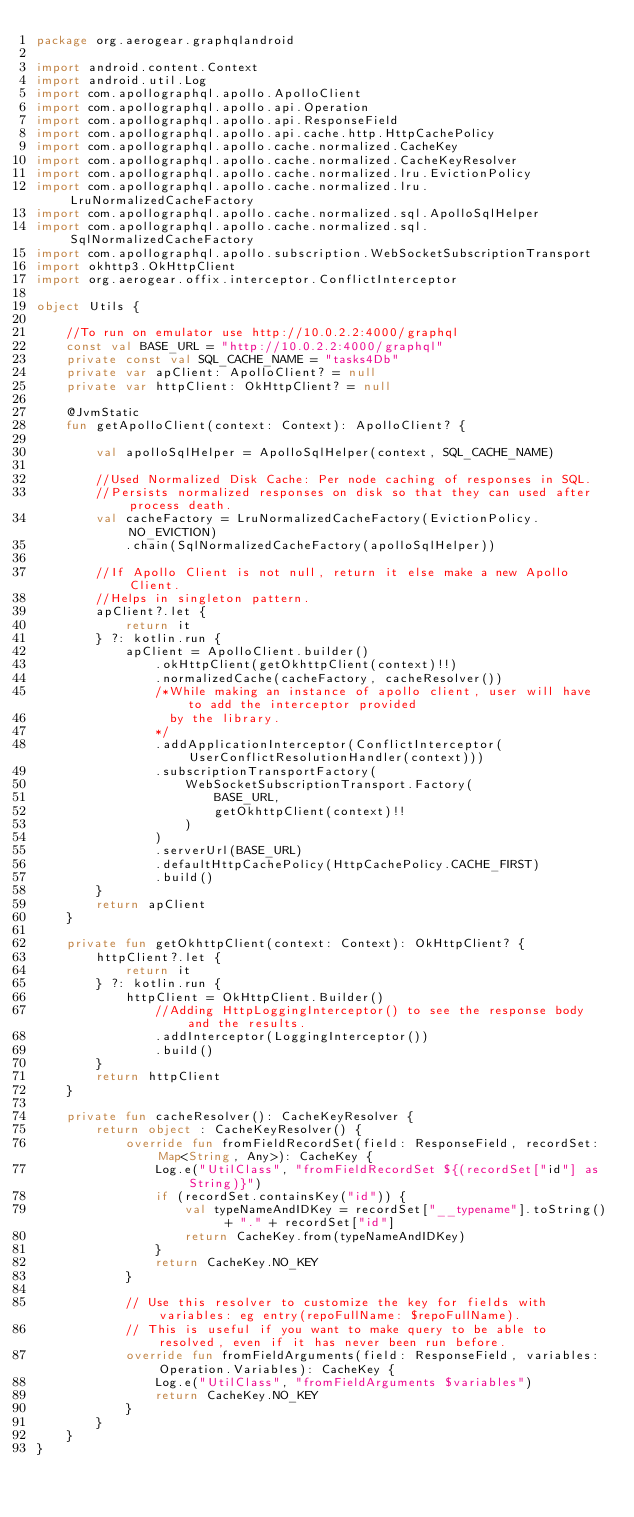<code> <loc_0><loc_0><loc_500><loc_500><_Kotlin_>package org.aerogear.graphqlandroid

import android.content.Context
import android.util.Log
import com.apollographql.apollo.ApolloClient
import com.apollographql.apollo.api.Operation
import com.apollographql.apollo.api.ResponseField
import com.apollographql.apollo.api.cache.http.HttpCachePolicy
import com.apollographql.apollo.cache.normalized.CacheKey
import com.apollographql.apollo.cache.normalized.CacheKeyResolver
import com.apollographql.apollo.cache.normalized.lru.EvictionPolicy
import com.apollographql.apollo.cache.normalized.lru.LruNormalizedCacheFactory
import com.apollographql.apollo.cache.normalized.sql.ApolloSqlHelper
import com.apollographql.apollo.cache.normalized.sql.SqlNormalizedCacheFactory
import com.apollographql.apollo.subscription.WebSocketSubscriptionTransport
import okhttp3.OkHttpClient
import org.aerogear.offix.interceptor.ConflictInterceptor

object Utils {

    //To run on emulator use http://10.0.2.2:4000/graphql
    const val BASE_URL = "http://10.0.2.2:4000/graphql"
    private const val SQL_CACHE_NAME = "tasks4Db"
    private var apClient: ApolloClient? = null
    private var httpClient: OkHttpClient? = null

    @JvmStatic
    fun getApolloClient(context: Context): ApolloClient? {

        val apolloSqlHelper = ApolloSqlHelper(context, SQL_CACHE_NAME)

        //Used Normalized Disk Cache: Per node caching of responses in SQL.
        //Persists normalized responses on disk so that they can used after process death.
        val cacheFactory = LruNormalizedCacheFactory(EvictionPolicy.NO_EVICTION)
            .chain(SqlNormalizedCacheFactory(apolloSqlHelper))

        //If Apollo Client is not null, return it else make a new Apollo Client.
        //Helps in singleton pattern.
        apClient?.let {
            return it
        } ?: kotlin.run {
            apClient = ApolloClient.builder()
                .okHttpClient(getOkhttpClient(context)!!)
                .normalizedCache(cacheFactory, cacheResolver())
                /*While making an instance of apollo client, user will have to add the interceptor provided
                  by the library.
                */
                .addApplicationInterceptor(ConflictInterceptor(UserConflictResolutionHandler(context)))
                .subscriptionTransportFactory(
                    WebSocketSubscriptionTransport.Factory(
                        BASE_URL,
                        getOkhttpClient(context)!!
                    )
                )
                .serverUrl(BASE_URL)
                .defaultHttpCachePolicy(HttpCachePolicy.CACHE_FIRST)
                .build()
        }
        return apClient
    }

    private fun getOkhttpClient(context: Context): OkHttpClient? {
        httpClient?.let {
            return it
        } ?: kotlin.run {
            httpClient = OkHttpClient.Builder()
                //Adding HttpLoggingInterceptor() to see the response body and the results.
                .addInterceptor(LoggingInterceptor())
                .build()
        }
        return httpClient
    }

    private fun cacheResolver(): CacheKeyResolver {
        return object : CacheKeyResolver() {
            override fun fromFieldRecordSet(field: ResponseField, recordSet: Map<String, Any>): CacheKey {
                Log.e("UtilClass", "fromFieldRecordSet ${(recordSet["id"] as String)}")
                if (recordSet.containsKey("id")) {
                    val typeNameAndIDKey = recordSet["__typename"].toString() + "." + recordSet["id"]
                    return CacheKey.from(typeNameAndIDKey)
                }
                return CacheKey.NO_KEY
            }

            // Use this resolver to customize the key for fields with variables: eg entry(repoFullName: $repoFullName).
            // This is useful if you want to make query to be able to resolved, even if it has never been run before.
            override fun fromFieldArguments(field: ResponseField, variables: Operation.Variables): CacheKey {
                Log.e("UtilClass", "fromFieldArguments $variables")
                return CacheKey.NO_KEY
            }
        }
    }
}

</code> 